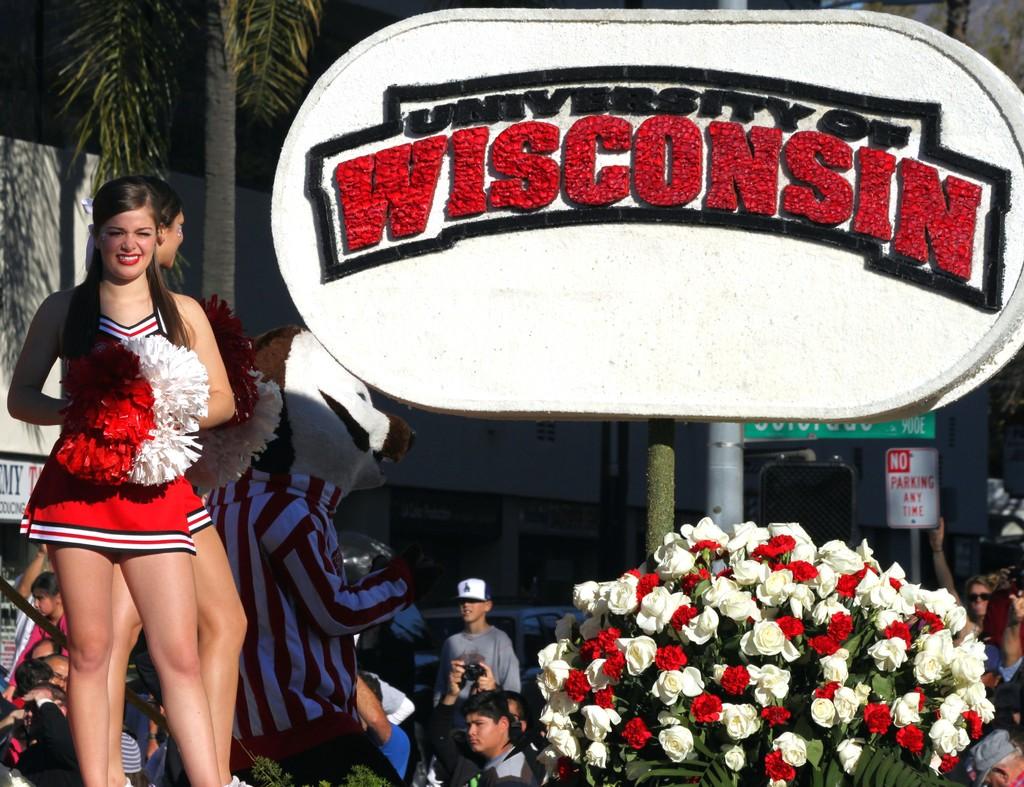What does the sign say about parking?
Offer a terse response. No parking. 